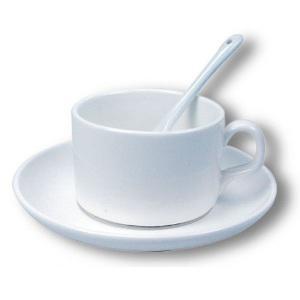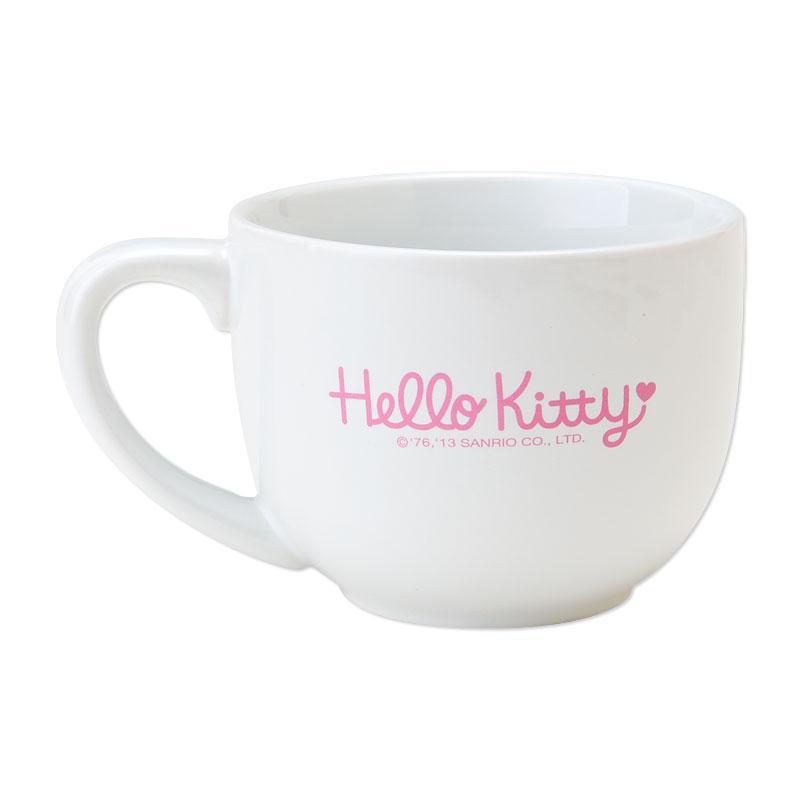The first image is the image on the left, the second image is the image on the right. Evaluate the accuracy of this statement regarding the images: "A spoon is on the surface in front of the cup.". Is it true? Answer yes or no. No. 